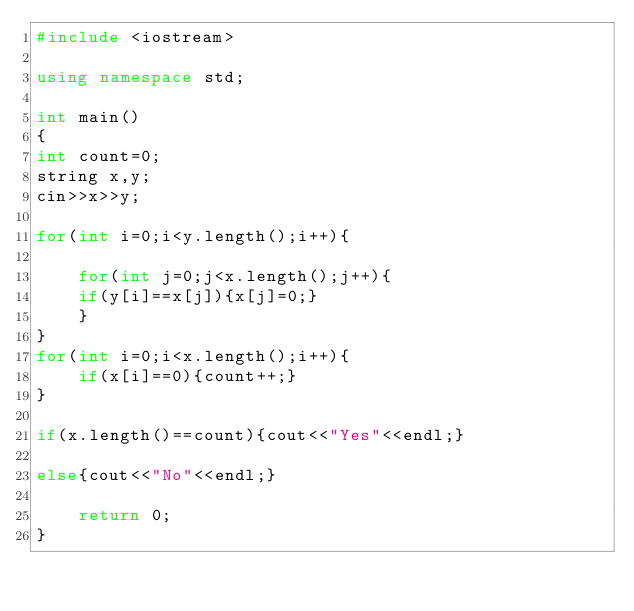<code> <loc_0><loc_0><loc_500><loc_500><_C++_>#include <iostream>

using namespace std;

int main()
{
int count=0;
string x,y;
cin>>x>>y;

for(int i=0;i<y.length();i++){

    for(int j=0;j<x.length();j++){
    if(y[i]==x[j]){x[j]=0;}
    }
}
for(int i=0;i<x.length();i++){
    if(x[i]==0){count++;}
}

if(x.length()==count){cout<<"Yes"<<endl;}

else{cout<<"No"<<endl;}

    return 0;
}</code> 